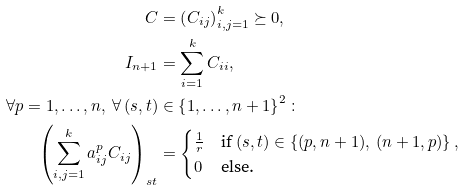Convert formula to latex. <formula><loc_0><loc_0><loc_500><loc_500>C & = \left ( C _ { i j } \right ) _ { i , j = 1 } ^ { k } \succeq 0 , \\ I _ { n + 1 } & = \sum _ { i = 1 } ^ { k } C _ { i i } , \\ \forall p = 1 , \dots , n , \ \forall \, ( s , t ) & \in \left \{ 1 , \dots , n + 1 \right \} ^ { 2 } \colon \\ \left ( \sum _ { i , j = 1 } ^ { k } a ^ { p } _ { i j } C _ { i j } \right ) _ { s t } & = \begin{cases} \frac { 1 } { r } & \text {if } ( s , t ) \in \left \{ ( p , n + 1 ) , \, ( n + 1 , p ) \right \} , \\ 0 & \text {else.} \end{cases}</formula> 